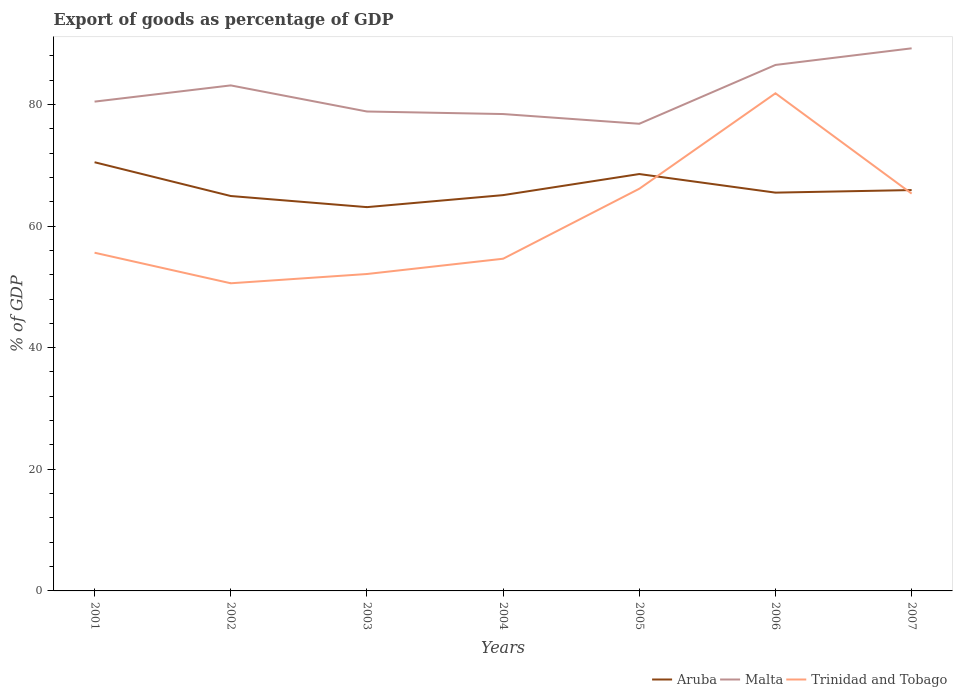How many different coloured lines are there?
Provide a succinct answer. 3. Across all years, what is the maximum export of goods as percentage of GDP in Aruba?
Give a very brief answer. 63.11. What is the total export of goods as percentage of GDP in Trinidad and Tobago in the graph?
Your answer should be very brief. -15.54. What is the difference between the highest and the second highest export of goods as percentage of GDP in Malta?
Offer a very short reply. 12.4. How many years are there in the graph?
Offer a very short reply. 7. What is the difference between two consecutive major ticks on the Y-axis?
Provide a succinct answer. 20. Are the values on the major ticks of Y-axis written in scientific E-notation?
Keep it short and to the point. No. Does the graph contain any zero values?
Provide a succinct answer. No. Where does the legend appear in the graph?
Give a very brief answer. Bottom right. How many legend labels are there?
Offer a very short reply. 3. How are the legend labels stacked?
Give a very brief answer. Horizontal. What is the title of the graph?
Make the answer very short. Export of goods as percentage of GDP. What is the label or title of the X-axis?
Your response must be concise. Years. What is the label or title of the Y-axis?
Provide a short and direct response. % of GDP. What is the % of GDP of Aruba in 2001?
Offer a terse response. 70.49. What is the % of GDP in Malta in 2001?
Give a very brief answer. 80.45. What is the % of GDP in Trinidad and Tobago in 2001?
Offer a very short reply. 55.61. What is the % of GDP of Aruba in 2002?
Your response must be concise. 64.93. What is the % of GDP of Malta in 2002?
Your response must be concise. 83.12. What is the % of GDP of Trinidad and Tobago in 2002?
Your response must be concise. 50.59. What is the % of GDP in Aruba in 2003?
Provide a succinct answer. 63.11. What is the % of GDP in Malta in 2003?
Provide a succinct answer. 78.83. What is the % of GDP of Trinidad and Tobago in 2003?
Give a very brief answer. 52.11. What is the % of GDP in Aruba in 2004?
Provide a succinct answer. 65.08. What is the % of GDP in Malta in 2004?
Give a very brief answer. 78.41. What is the % of GDP of Trinidad and Tobago in 2004?
Your response must be concise. 54.62. What is the % of GDP of Aruba in 2005?
Make the answer very short. 68.55. What is the % of GDP of Malta in 2005?
Your answer should be very brief. 76.81. What is the % of GDP of Trinidad and Tobago in 2005?
Your answer should be compact. 66.13. What is the % of GDP in Aruba in 2006?
Keep it short and to the point. 65.49. What is the % of GDP of Malta in 2006?
Your answer should be compact. 86.49. What is the % of GDP of Trinidad and Tobago in 2006?
Keep it short and to the point. 81.83. What is the % of GDP of Aruba in 2007?
Give a very brief answer. 65.91. What is the % of GDP of Malta in 2007?
Make the answer very short. 89.22. What is the % of GDP in Trinidad and Tobago in 2007?
Keep it short and to the point. 65.33. Across all years, what is the maximum % of GDP of Aruba?
Keep it short and to the point. 70.49. Across all years, what is the maximum % of GDP in Malta?
Your answer should be very brief. 89.22. Across all years, what is the maximum % of GDP in Trinidad and Tobago?
Offer a very short reply. 81.83. Across all years, what is the minimum % of GDP in Aruba?
Ensure brevity in your answer.  63.11. Across all years, what is the minimum % of GDP in Malta?
Keep it short and to the point. 76.81. Across all years, what is the minimum % of GDP of Trinidad and Tobago?
Offer a very short reply. 50.59. What is the total % of GDP of Aruba in the graph?
Provide a succinct answer. 463.56. What is the total % of GDP in Malta in the graph?
Provide a succinct answer. 573.34. What is the total % of GDP of Trinidad and Tobago in the graph?
Offer a terse response. 426.21. What is the difference between the % of GDP of Aruba in 2001 and that in 2002?
Ensure brevity in your answer.  5.55. What is the difference between the % of GDP of Malta in 2001 and that in 2002?
Your answer should be very brief. -2.67. What is the difference between the % of GDP of Trinidad and Tobago in 2001 and that in 2002?
Keep it short and to the point. 5.02. What is the difference between the % of GDP of Aruba in 2001 and that in 2003?
Your answer should be very brief. 7.38. What is the difference between the % of GDP of Malta in 2001 and that in 2003?
Your answer should be very brief. 1.62. What is the difference between the % of GDP of Trinidad and Tobago in 2001 and that in 2003?
Make the answer very short. 3.5. What is the difference between the % of GDP in Aruba in 2001 and that in 2004?
Provide a succinct answer. 5.41. What is the difference between the % of GDP in Malta in 2001 and that in 2004?
Keep it short and to the point. 2.04. What is the difference between the % of GDP of Aruba in 2001 and that in 2005?
Your answer should be very brief. 1.94. What is the difference between the % of GDP of Malta in 2001 and that in 2005?
Make the answer very short. 3.64. What is the difference between the % of GDP of Trinidad and Tobago in 2001 and that in 2005?
Ensure brevity in your answer.  -10.52. What is the difference between the % of GDP in Aruba in 2001 and that in 2006?
Keep it short and to the point. 5. What is the difference between the % of GDP of Malta in 2001 and that in 2006?
Provide a short and direct response. -6.03. What is the difference between the % of GDP in Trinidad and Tobago in 2001 and that in 2006?
Provide a short and direct response. -26.21. What is the difference between the % of GDP of Aruba in 2001 and that in 2007?
Provide a succinct answer. 4.58. What is the difference between the % of GDP in Malta in 2001 and that in 2007?
Your answer should be compact. -8.76. What is the difference between the % of GDP of Trinidad and Tobago in 2001 and that in 2007?
Your response must be concise. -9.72. What is the difference between the % of GDP of Aruba in 2002 and that in 2003?
Offer a terse response. 1.83. What is the difference between the % of GDP of Malta in 2002 and that in 2003?
Make the answer very short. 4.29. What is the difference between the % of GDP of Trinidad and Tobago in 2002 and that in 2003?
Provide a short and direct response. -1.52. What is the difference between the % of GDP in Aruba in 2002 and that in 2004?
Ensure brevity in your answer.  -0.15. What is the difference between the % of GDP of Malta in 2002 and that in 2004?
Your answer should be compact. 4.71. What is the difference between the % of GDP of Trinidad and Tobago in 2002 and that in 2004?
Offer a very short reply. -4.04. What is the difference between the % of GDP of Aruba in 2002 and that in 2005?
Provide a succinct answer. -3.61. What is the difference between the % of GDP in Malta in 2002 and that in 2005?
Offer a very short reply. 6.31. What is the difference between the % of GDP in Trinidad and Tobago in 2002 and that in 2005?
Provide a short and direct response. -15.54. What is the difference between the % of GDP in Aruba in 2002 and that in 2006?
Your answer should be compact. -0.56. What is the difference between the % of GDP in Malta in 2002 and that in 2006?
Offer a very short reply. -3.36. What is the difference between the % of GDP in Trinidad and Tobago in 2002 and that in 2006?
Your answer should be compact. -31.24. What is the difference between the % of GDP in Aruba in 2002 and that in 2007?
Your answer should be compact. -0.98. What is the difference between the % of GDP in Malta in 2002 and that in 2007?
Make the answer very short. -6.1. What is the difference between the % of GDP in Trinidad and Tobago in 2002 and that in 2007?
Offer a terse response. -14.74. What is the difference between the % of GDP of Aruba in 2003 and that in 2004?
Your answer should be very brief. -1.97. What is the difference between the % of GDP of Malta in 2003 and that in 2004?
Keep it short and to the point. 0.42. What is the difference between the % of GDP of Trinidad and Tobago in 2003 and that in 2004?
Your response must be concise. -2.51. What is the difference between the % of GDP of Aruba in 2003 and that in 2005?
Provide a succinct answer. -5.44. What is the difference between the % of GDP of Malta in 2003 and that in 2005?
Provide a short and direct response. 2.02. What is the difference between the % of GDP in Trinidad and Tobago in 2003 and that in 2005?
Give a very brief answer. -14.02. What is the difference between the % of GDP in Aruba in 2003 and that in 2006?
Offer a very short reply. -2.38. What is the difference between the % of GDP in Malta in 2003 and that in 2006?
Your response must be concise. -7.65. What is the difference between the % of GDP of Trinidad and Tobago in 2003 and that in 2006?
Keep it short and to the point. -29.72. What is the difference between the % of GDP in Aruba in 2003 and that in 2007?
Ensure brevity in your answer.  -2.81. What is the difference between the % of GDP of Malta in 2003 and that in 2007?
Keep it short and to the point. -10.39. What is the difference between the % of GDP in Trinidad and Tobago in 2003 and that in 2007?
Make the answer very short. -13.22. What is the difference between the % of GDP of Aruba in 2004 and that in 2005?
Give a very brief answer. -3.47. What is the difference between the % of GDP of Malta in 2004 and that in 2005?
Make the answer very short. 1.6. What is the difference between the % of GDP of Trinidad and Tobago in 2004 and that in 2005?
Keep it short and to the point. -11.51. What is the difference between the % of GDP in Aruba in 2004 and that in 2006?
Your response must be concise. -0.41. What is the difference between the % of GDP in Malta in 2004 and that in 2006?
Ensure brevity in your answer.  -8.07. What is the difference between the % of GDP in Trinidad and Tobago in 2004 and that in 2006?
Provide a short and direct response. -27.2. What is the difference between the % of GDP of Aruba in 2004 and that in 2007?
Offer a terse response. -0.83. What is the difference between the % of GDP in Malta in 2004 and that in 2007?
Provide a succinct answer. -10.81. What is the difference between the % of GDP of Trinidad and Tobago in 2004 and that in 2007?
Ensure brevity in your answer.  -10.71. What is the difference between the % of GDP of Aruba in 2005 and that in 2006?
Your answer should be compact. 3.06. What is the difference between the % of GDP of Malta in 2005 and that in 2006?
Offer a terse response. -9.67. What is the difference between the % of GDP of Trinidad and Tobago in 2005 and that in 2006?
Provide a short and direct response. -15.7. What is the difference between the % of GDP of Aruba in 2005 and that in 2007?
Provide a succinct answer. 2.63. What is the difference between the % of GDP of Malta in 2005 and that in 2007?
Your response must be concise. -12.4. What is the difference between the % of GDP of Trinidad and Tobago in 2005 and that in 2007?
Provide a succinct answer. 0.8. What is the difference between the % of GDP of Aruba in 2006 and that in 2007?
Ensure brevity in your answer.  -0.42. What is the difference between the % of GDP in Malta in 2006 and that in 2007?
Provide a succinct answer. -2.73. What is the difference between the % of GDP in Trinidad and Tobago in 2006 and that in 2007?
Give a very brief answer. 16.5. What is the difference between the % of GDP in Aruba in 2001 and the % of GDP in Malta in 2002?
Provide a succinct answer. -12.63. What is the difference between the % of GDP of Aruba in 2001 and the % of GDP of Trinidad and Tobago in 2002?
Your response must be concise. 19.9. What is the difference between the % of GDP of Malta in 2001 and the % of GDP of Trinidad and Tobago in 2002?
Make the answer very short. 29.87. What is the difference between the % of GDP in Aruba in 2001 and the % of GDP in Malta in 2003?
Offer a very short reply. -8.34. What is the difference between the % of GDP in Aruba in 2001 and the % of GDP in Trinidad and Tobago in 2003?
Keep it short and to the point. 18.38. What is the difference between the % of GDP in Malta in 2001 and the % of GDP in Trinidad and Tobago in 2003?
Give a very brief answer. 28.35. What is the difference between the % of GDP in Aruba in 2001 and the % of GDP in Malta in 2004?
Offer a terse response. -7.92. What is the difference between the % of GDP of Aruba in 2001 and the % of GDP of Trinidad and Tobago in 2004?
Give a very brief answer. 15.87. What is the difference between the % of GDP in Malta in 2001 and the % of GDP in Trinidad and Tobago in 2004?
Make the answer very short. 25.83. What is the difference between the % of GDP of Aruba in 2001 and the % of GDP of Malta in 2005?
Your answer should be very brief. -6.33. What is the difference between the % of GDP of Aruba in 2001 and the % of GDP of Trinidad and Tobago in 2005?
Offer a terse response. 4.36. What is the difference between the % of GDP of Malta in 2001 and the % of GDP of Trinidad and Tobago in 2005?
Keep it short and to the point. 14.33. What is the difference between the % of GDP of Aruba in 2001 and the % of GDP of Malta in 2006?
Your answer should be very brief. -16. What is the difference between the % of GDP of Aruba in 2001 and the % of GDP of Trinidad and Tobago in 2006?
Give a very brief answer. -11.34. What is the difference between the % of GDP in Malta in 2001 and the % of GDP in Trinidad and Tobago in 2006?
Offer a very short reply. -1.37. What is the difference between the % of GDP in Aruba in 2001 and the % of GDP in Malta in 2007?
Make the answer very short. -18.73. What is the difference between the % of GDP of Aruba in 2001 and the % of GDP of Trinidad and Tobago in 2007?
Provide a short and direct response. 5.16. What is the difference between the % of GDP in Malta in 2001 and the % of GDP in Trinidad and Tobago in 2007?
Your answer should be compact. 15.12. What is the difference between the % of GDP in Aruba in 2002 and the % of GDP in Malta in 2003?
Ensure brevity in your answer.  -13.9. What is the difference between the % of GDP in Aruba in 2002 and the % of GDP in Trinidad and Tobago in 2003?
Provide a succinct answer. 12.82. What is the difference between the % of GDP in Malta in 2002 and the % of GDP in Trinidad and Tobago in 2003?
Offer a terse response. 31.01. What is the difference between the % of GDP of Aruba in 2002 and the % of GDP of Malta in 2004?
Keep it short and to the point. -13.48. What is the difference between the % of GDP in Aruba in 2002 and the % of GDP in Trinidad and Tobago in 2004?
Your response must be concise. 10.31. What is the difference between the % of GDP in Malta in 2002 and the % of GDP in Trinidad and Tobago in 2004?
Keep it short and to the point. 28.5. What is the difference between the % of GDP of Aruba in 2002 and the % of GDP of Malta in 2005?
Keep it short and to the point. -11.88. What is the difference between the % of GDP in Aruba in 2002 and the % of GDP in Trinidad and Tobago in 2005?
Offer a very short reply. -1.19. What is the difference between the % of GDP of Malta in 2002 and the % of GDP of Trinidad and Tobago in 2005?
Offer a very short reply. 16.99. What is the difference between the % of GDP in Aruba in 2002 and the % of GDP in Malta in 2006?
Your response must be concise. -21.55. What is the difference between the % of GDP of Aruba in 2002 and the % of GDP of Trinidad and Tobago in 2006?
Your answer should be compact. -16.89. What is the difference between the % of GDP of Malta in 2002 and the % of GDP of Trinidad and Tobago in 2006?
Give a very brief answer. 1.3. What is the difference between the % of GDP in Aruba in 2002 and the % of GDP in Malta in 2007?
Your answer should be very brief. -24.28. What is the difference between the % of GDP of Aruba in 2002 and the % of GDP of Trinidad and Tobago in 2007?
Offer a terse response. -0.4. What is the difference between the % of GDP in Malta in 2002 and the % of GDP in Trinidad and Tobago in 2007?
Offer a terse response. 17.79. What is the difference between the % of GDP of Aruba in 2003 and the % of GDP of Malta in 2004?
Give a very brief answer. -15.31. What is the difference between the % of GDP in Aruba in 2003 and the % of GDP in Trinidad and Tobago in 2004?
Your response must be concise. 8.48. What is the difference between the % of GDP of Malta in 2003 and the % of GDP of Trinidad and Tobago in 2004?
Ensure brevity in your answer.  24.21. What is the difference between the % of GDP of Aruba in 2003 and the % of GDP of Malta in 2005?
Offer a terse response. -13.71. What is the difference between the % of GDP of Aruba in 2003 and the % of GDP of Trinidad and Tobago in 2005?
Provide a succinct answer. -3.02. What is the difference between the % of GDP of Malta in 2003 and the % of GDP of Trinidad and Tobago in 2005?
Provide a short and direct response. 12.7. What is the difference between the % of GDP of Aruba in 2003 and the % of GDP of Malta in 2006?
Keep it short and to the point. -23.38. What is the difference between the % of GDP in Aruba in 2003 and the % of GDP in Trinidad and Tobago in 2006?
Keep it short and to the point. -18.72. What is the difference between the % of GDP of Malta in 2003 and the % of GDP of Trinidad and Tobago in 2006?
Make the answer very short. -2.99. What is the difference between the % of GDP of Aruba in 2003 and the % of GDP of Malta in 2007?
Your answer should be compact. -26.11. What is the difference between the % of GDP of Aruba in 2003 and the % of GDP of Trinidad and Tobago in 2007?
Your answer should be compact. -2.22. What is the difference between the % of GDP in Malta in 2003 and the % of GDP in Trinidad and Tobago in 2007?
Give a very brief answer. 13.5. What is the difference between the % of GDP in Aruba in 2004 and the % of GDP in Malta in 2005?
Ensure brevity in your answer.  -11.73. What is the difference between the % of GDP in Aruba in 2004 and the % of GDP in Trinidad and Tobago in 2005?
Provide a short and direct response. -1.05. What is the difference between the % of GDP of Malta in 2004 and the % of GDP of Trinidad and Tobago in 2005?
Provide a short and direct response. 12.28. What is the difference between the % of GDP of Aruba in 2004 and the % of GDP of Malta in 2006?
Keep it short and to the point. -21.41. What is the difference between the % of GDP in Aruba in 2004 and the % of GDP in Trinidad and Tobago in 2006?
Give a very brief answer. -16.75. What is the difference between the % of GDP in Malta in 2004 and the % of GDP in Trinidad and Tobago in 2006?
Make the answer very short. -3.41. What is the difference between the % of GDP of Aruba in 2004 and the % of GDP of Malta in 2007?
Your response must be concise. -24.14. What is the difference between the % of GDP of Malta in 2004 and the % of GDP of Trinidad and Tobago in 2007?
Your response must be concise. 13.08. What is the difference between the % of GDP in Aruba in 2005 and the % of GDP in Malta in 2006?
Your response must be concise. -17.94. What is the difference between the % of GDP of Aruba in 2005 and the % of GDP of Trinidad and Tobago in 2006?
Offer a terse response. -13.28. What is the difference between the % of GDP of Malta in 2005 and the % of GDP of Trinidad and Tobago in 2006?
Keep it short and to the point. -5.01. What is the difference between the % of GDP of Aruba in 2005 and the % of GDP of Malta in 2007?
Give a very brief answer. -20.67. What is the difference between the % of GDP in Aruba in 2005 and the % of GDP in Trinidad and Tobago in 2007?
Give a very brief answer. 3.22. What is the difference between the % of GDP of Malta in 2005 and the % of GDP of Trinidad and Tobago in 2007?
Your response must be concise. 11.48. What is the difference between the % of GDP of Aruba in 2006 and the % of GDP of Malta in 2007?
Offer a terse response. -23.73. What is the difference between the % of GDP of Aruba in 2006 and the % of GDP of Trinidad and Tobago in 2007?
Your response must be concise. 0.16. What is the difference between the % of GDP of Malta in 2006 and the % of GDP of Trinidad and Tobago in 2007?
Provide a short and direct response. 21.16. What is the average % of GDP in Aruba per year?
Offer a very short reply. 66.22. What is the average % of GDP in Malta per year?
Provide a succinct answer. 81.91. What is the average % of GDP of Trinidad and Tobago per year?
Offer a terse response. 60.89. In the year 2001, what is the difference between the % of GDP of Aruba and % of GDP of Malta?
Keep it short and to the point. -9.97. In the year 2001, what is the difference between the % of GDP of Aruba and % of GDP of Trinidad and Tobago?
Offer a terse response. 14.88. In the year 2001, what is the difference between the % of GDP in Malta and % of GDP in Trinidad and Tobago?
Offer a very short reply. 24.84. In the year 2002, what is the difference between the % of GDP of Aruba and % of GDP of Malta?
Offer a very short reply. -18.19. In the year 2002, what is the difference between the % of GDP in Aruba and % of GDP in Trinidad and Tobago?
Your answer should be very brief. 14.35. In the year 2002, what is the difference between the % of GDP of Malta and % of GDP of Trinidad and Tobago?
Provide a succinct answer. 32.54. In the year 2003, what is the difference between the % of GDP of Aruba and % of GDP of Malta?
Offer a terse response. -15.73. In the year 2003, what is the difference between the % of GDP of Aruba and % of GDP of Trinidad and Tobago?
Provide a succinct answer. 11. In the year 2003, what is the difference between the % of GDP of Malta and % of GDP of Trinidad and Tobago?
Your answer should be compact. 26.72. In the year 2004, what is the difference between the % of GDP of Aruba and % of GDP of Malta?
Make the answer very short. -13.33. In the year 2004, what is the difference between the % of GDP of Aruba and % of GDP of Trinidad and Tobago?
Provide a succinct answer. 10.46. In the year 2004, what is the difference between the % of GDP in Malta and % of GDP in Trinidad and Tobago?
Your answer should be compact. 23.79. In the year 2005, what is the difference between the % of GDP in Aruba and % of GDP in Malta?
Your response must be concise. -8.27. In the year 2005, what is the difference between the % of GDP of Aruba and % of GDP of Trinidad and Tobago?
Offer a terse response. 2.42. In the year 2005, what is the difference between the % of GDP in Malta and % of GDP in Trinidad and Tobago?
Offer a terse response. 10.69. In the year 2006, what is the difference between the % of GDP of Aruba and % of GDP of Malta?
Give a very brief answer. -21. In the year 2006, what is the difference between the % of GDP of Aruba and % of GDP of Trinidad and Tobago?
Provide a short and direct response. -16.33. In the year 2006, what is the difference between the % of GDP of Malta and % of GDP of Trinidad and Tobago?
Offer a terse response. 4.66. In the year 2007, what is the difference between the % of GDP of Aruba and % of GDP of Malta?
Offer a terse response. -23.31. In the year 2007, what is the difference between the % of GDP of Aruba and % of GDP of Trinidad and Tobago?
Provide a short and direct response. 0.58. In the year 2007, what is the difference between the % of GDP of Malta and % of GDP of Trinidad and Tobago?
Your answer should be compact. 23.89. What is the ratio of the % of GDP of Aruba in 2001 to that in 2002?
Your answer should be compact. 1.09. What is the ratio of the % of GDP of Malta in 2001 to that in 2002?
Keep it short and to the point. 0.97. What is the ratio of the % of GDP of Trinidad and Tobago in 2001 to that in 2002?
Your answer should be compact. 1.1. What is the ratio of the % of GDP of Aruba in 2001 to that in 2003?
Offer a terse response. 1.12. What is the ratio of the % of GDP of Malta in 2001 to that in 2003?
Offer a very short reply. 1.02. What is the ratio of the % of GDP of Trinidad and Tobago in 2001 to that in 2003?
Make the answer very short. 1.07. What is the ratio of the % of GDP of Aruba in 2001 to that in 2004?
Your answer should be compact. 1.08. What is the ratio of the % of GDP of Malta in 2001 to that in 2004?
Offer a very short reply. 1.03. What is the ratio of the % of GDP of Trinidad and Tobago in 2001 to that in 2004?
Provide a succinct answer. 1.02. What is the ratio of the % of GDP in Aruba in 2001 to that in 2005?
Ensure brevity in your answer.  1.03. What is the ratio of the % of GDP of Malta in 2001 to that in 2005?
Provide a succinct answer. 1.05. What is the ratio of the % of GDP of Trinidad and Tobago in 2001 to that in 2005?
Offer a terse response. 0.84. What is the ratio of the % of GDP in Aruba in 2001 to that in 2006?
Your response must be concise. 1.08. What is the ratio of the % of GDP of Malta in 2001 to that in 2006?
Provide a succinct answer. 0.93. What is the ratio of the % of GDP in Trinidad and Tobago in 2001 to that in 2006?
Provide a short and direct response. 0.68. What is the ratio of the % of GDP in Aruba in 2001 to that in 2007?
Offer a very short reply. 1.07. What is the ratio of the % of GDP of Malta in 2001 to that in 2007?
Provide a succinct answer. 0.9. What is the ratio of the % of GDP of Trinidad and Tobago in 2001 to that in 2007?
Offer a terse response. 0.85. What is the ratio of the % of GDP in Malta in 2002 to that in 2003?
Ensure brevity in your answer.  1.05. What is the ratio of the % of GDP of Trinidad and Tobago in 2002 to that in 2003?
Your answer should be compact. 0.97. What is the ratio of the % of GDP of Aruba in 2002 to that in 2004?
Keep it short and to the point. 1. What is the ratio of the % of GDP of Malta in 2002 to that in 2004?
Give a very brief answer. 1.06. What is the ratio of the % of GDP in Trinidad and Tobago in 2002 to that in 2004?
Make the answer very short. 0.93. What is the ratio of the % of GDP in Aruba in 2002 to that in 2005?
Provide a succinct answer. 0.95. What is the ratio of the % of GDP of Malta in 2002 to that in 2005?
Offer a very short reply. 1.08. What is the ratio of the % of GDP of Trinidad and Tobago in 2002 to that in 2005?
Ensure brevity in your answer.  0.77. What is the ratio of the % of GDP in Aruba in 2002 to that in 2006?
Offer a terse response. 0.99. What is the ratio of the % of GDP in Malta in 2002 to that in 2006?
Offer a terse response. 0.96. What is the ratio of the % of GDP of Trinidad and Tobago in 2002 to that in 2006?
Make the answer very short. 0.62. What is the ratio of the % of GDP of Aruba in 2002 to that in 2007?
Offer a terse response. 0.99. What is the ratio of the % of GDP in Malta in 2002 to that in 2007?
Ensure brevity in your answer.  0.93. What is the ratio of the % of GDP of Trinidad and Tobago in 2002 to that in 2007?
Provide a short and direct response. 0.77. What is the ratio of the % of GDP of Aruba in 2003 to that in 2004?
Provide a short and direct response. 0.97. What is the ratio of the % of GDP of Malta in 2003 to that in 2004?
Ensure brevity in your answer.  1.01. What is the ratio of the % of GDP in Trinidad and Tobago in 2003 to that in 2004?
Provide a succinct answer. 0.95. What is the ratio of the % of GDP in Aruba in 2003 to that in 2005?
Make the answer very short. 0.92. What is the ratio of the % of GDP of Malta in 2003 to that in 2005?
Offer a very short reply. 1.03. What is the ratio of the % of GDP of Trinidad and Tobago in 2003 to that in 2005?
Offer a very short reply. 0.79. What is the ratio of the % of GDP in Aruba in 2003 to that in 2006?
Give a very brief answer. 0.96. What is the ratio of the % of GDP in Malta in 2003 to that in 2006?
Your response must be concise. 0.91. What is the ratio of the % of GDP of Trinidad and Tobago in 2003 to that in 2006?
Give a very brief answer. 0.64. What is the ratio of the % of GDP of Aruba in 2003 to that in 2007?
Your response must be concise. 0.96. What is the ratio of the % of GDP of Malta in 2003 to that in 2007?
Offer a very short reply. 0.88. What is the ratio of the % of GDP of Trinidad and Tobago in 2003 to that in 2007?
Your response must be concise. 0.8. What is the ratio of the % of GDP in Aruba in 2004 to that in 2005?
Offer a very short reply. 0.95. What is the ratio of the % of GDP in Malta in 2004 to that in 2005?
Provide a short and direct response. 1.02. What is the ratio of the % of GDP of Trinidad and Tobago in 2004 to that in 2005?
Ensure brevity in your answer.  0.83. What is the ratio of the % of GDP in Aruba in 2004 to that in 2006?
Give a very brief answer. 0.99. What is the ratio of the % of GDP in Malta in 2004 to that in 2006?
Keep it short and to the point. 0.91. What is the ratio of the % of GDP of Trinidad and Tobago in 2004 to that in 2006?
Offer a very short reply. 0.67. What is the ratio of the % of GDP of Aruba in 2004 to that in 2007?
Provide a succinct answer. 0.99. What is the ratio of the % of GDP in Malta in 2004 to that in 2007?
Your response must be concise. 0.88. What is the ratio of the % of GDP of Trinidad and Tobago in 2004 to that in 2007?
Ensure brevity in your answer.  0.84. What is the ratio of the % of GDP in Aruba in 2005 to that in 2006?
Ensure brevity in your answer.  1.05. What is the ratio of the % of GDP of Malta in 2005 to that in 2006?
Make the answer very short. 0.89. What is the ratio of the % of GDP of Trinidad and Tobago in 2005 to that in 2006?
Provide a short and direct response. 0.81. What is the ratio of the % of GDP in Malta in 2005 to that in 2007?
Offer a terse response. 0.86. What is the ratio of the % of GDP of Trinidad and Tobago in 2005 to that in 2007?
Offer a terse response. 1.01. What is the ratio of the % of GDP of Malta in 2006 to that in 2007?
Ensure brevity in your answer.  0.97. What is the ratio of the % of GDP of Trinidad and Tobago in 2006 to that in 2007?
Your answer should be very brief. 1.25. What is the difference between the highest and the second highest % of GDP of Aruba?
Give a very brief answer. 1.94. What is the difference between the highest and the second highest % of GDP of Malta?
Your answer should be compact. 2.73. What is the difference between the highest and the second highest % of GDP of Trinidad and Tobago?
Provide a short and direct response. 15.7. What is the difference between the highest and the lowest % of GDP in Aruba?
Offer a terse response. 7.38. What is the difference between the highest and the lowest % of GDP in Malta?
Make the answer very short. 12.4. What is the difference between the highest and the lowest % of GDP of Trinidad and Tobago?
Make the answer very short. 31.24. 